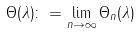<formula> <loc_0><loc_0><loc_500><loc_500>\Theta ( \lambda ) \colon = \lim _ { n \to \infty } \Theta _ { n } ( \lambda )</formula> 